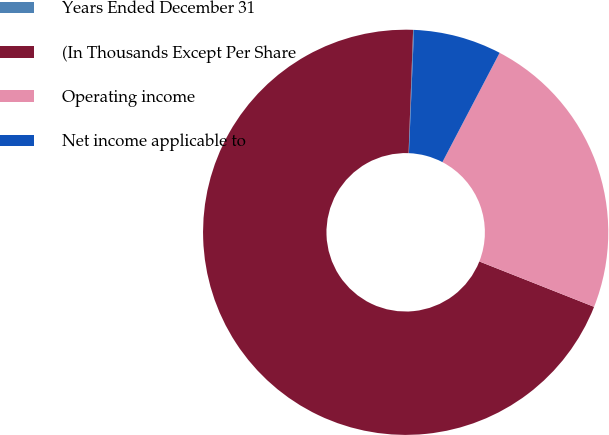Convert chart. <chart><loc_0><loc_0><loc_500><loc_500><pie_chart><fcel>Years Ended December 31<fcel>(In Thousands Except Per Share<fcel>Operating income<fcel>Net income applicable to<nl><fcel>0.07%<fcel>69.59%<fcel>23.32%<fcel>7.02%<nl></chart> 